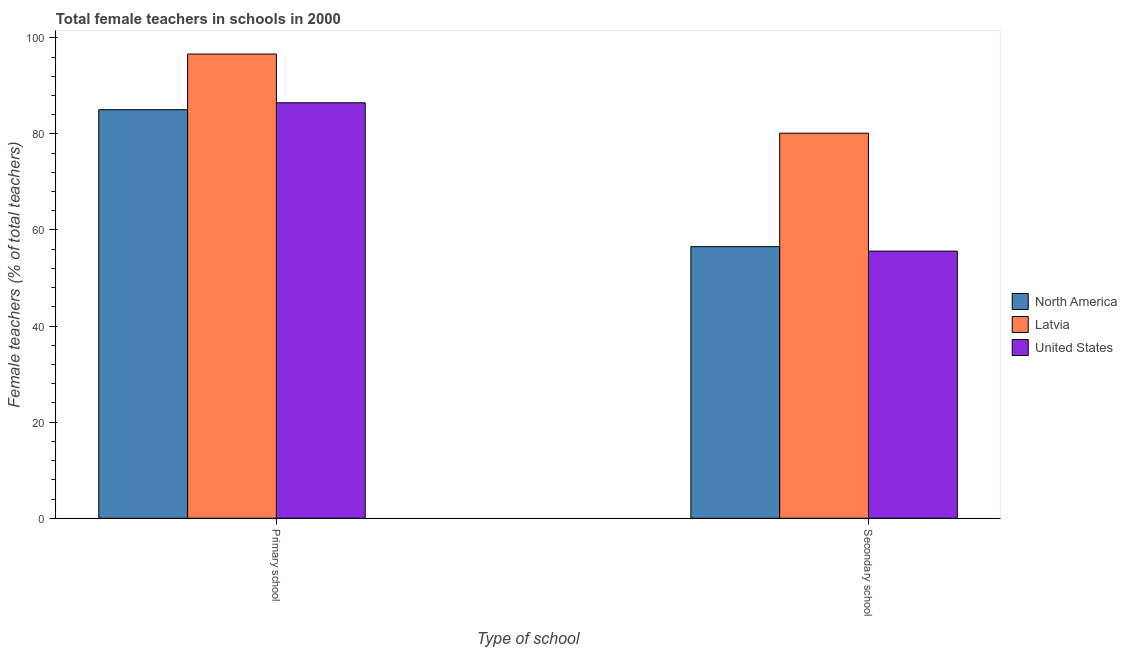Are the number of bars on each tick of the X-axis equal?
Your answer should be compact. Yes. How many bars are there on the 1st tick from the left?
Your answer should be very brief. 3. How many bars are there on the 2nd tick from the right?
Ensure brevity in your answer.  3. What is the label of the 2nd group of bars from the left?
Provide a succinct answer. Secondary school. What is the percentage of female teachers in primary schools in Latvia?
Offer a very short reply. 96.62. Across all countries, what is the maximum percentage of female teachers in primary schools?
Your answer should be very brief. 96.62. Across all countries, what is the minimum percentage of female teachers in secondary schools?
Make the answer very short. 55.6. In which country was the percentage of female teachers in secondary schools maximum?
Your answer should be compact. Latvia. In which country was the percentage of female teachers in primary schools minimum?
Your response must be concise. North America. What is the total percentage of female teachers in primary schools in the graph?
Offer a very short reply. 268.12. What is the difference between the percentage of female teachers in secondary schools in North America and that in Latvia?
Ensure brevity in your answer.  -23.62. What is the difference between the percentage of female teachers in secondary schools in United States and the percentage of female teachers in primary schools in North America?
Your response must be concise. -29.44. What is the average percentage of female teachers in primary schools per country?
Offer a terse response. 89.37. What is the difference between the percentage of female teachers in primary schools and percentage of female teachers in secondary schools in United States?
Make the answer very short. 30.87. What is the ratio of the percentage of female teachers in secondary schools in Latvia to that in United States?
Offer a very short reply. 1.44. Is the percentage of female teachers in primary schools in United States less than that in Latvia?
Your answer should be compact. Yes. What does the 2nd bar from the left in Secondary school represents?
Make the answer very short. Latvia. How many bars are there?
Your answer should be compact. 6. What is the difference between two consecutive major ticks on the Y-axis?
Ensure brevity in your answer.  20. Does the graph contain any zero values?
Make the answer very short. No. Does the graph contain grids?
Offer a terse response. No. Where does the legend appear in the graph?
Your response must be concise. Center right. What is the title of the graph?
Your answer should be compact. Total female teachers in schools in 2000. What is the label or title of the X-axis?
Provide a short and direct response. Type of school. What is the label or title of the Y-axis?
Give a very brief answer. Female teachers (% of total teachers). What is the Female teachers (% of total teachers) of North America in Primary school?
Your answer should be very brief. 85.03. What is the Female teachers (% of total teachers) in Latvia in Primary school?
Keep it short and to the point. 96.62. What is the Female teachers (% of total teachers) of United States in Primary school?
Provide a succinct answer. 86.47. What is the Female teachers (% of total teachers) of North America in Secondary school?
Keep it short and to the point. 56.52. What is the Female teachers (% of total teachers) in Latvia in Secondary school?
Your response must be concise. 80.14. What is the Female teachers (% of total teachers) of United States in Secondary school?
Provide a succinct answer. 55.6. Across all Type of school, what is the maximum Female teachers (% of total teachers) of North America?
Make the answer very short. 85.03. Across all Type of school, what is the maximum Female teachers (% of total teachers) in Latvia?
Offer a very short reply. 96.62. Across all Type of school, what is the maximum Female teachers (% of total teachers) in United States?
Your response must be concise. 86.47. Across all Type of school, what is the minimum Female teachers (% of total teachers) of North America?
Provide a short and direct response. 56.52. Across all Type of school, what is the minimum Female teachers (% of total teachers) of Latvia?
Your answer should be very brief. 80.14. Across all Type of school, what is the minimum Female teachers (% of total teachers) in United States?
Keep it short and to the point. 55.6. What is the total Female teachers (% of total teachers) in North America in the graph?
Your answer should be very brief. 141.56. What is the total Female teachers (% of total teachers) in Latvia in the graph?
Ensure brevity in your answer.  176.76. What is the total Female teachers (% of total teachers) in United States in the graph?
Give a very brief answer. 142.07. What is the difference between the Female teachers (% of total teachers) in North America in Primary school and that in Secondary school?
Provide a short and direct response. 28.51. What is the difference between the Female teachers (% of total teachers) in Latvia in Primary school and that in Secondary school?
Make the answer very short. 16.48. What is the difference between the Female teachers (% of total teachers) in United States in Primary school and that in Secondary school?
Offer a very short reply. 30.87. What is the difference between the Female teachers (% of total teachers) in North America in Primary school and the Female teachers (% of total teachers) in Latvia in Secondary school?
Make the answer very short. 4.89. What is the difference between the Female teachers (% of total teachers) in North America in Primary school and the Female teachers (% of total teachers) in United States in Secondary school?
Your answer should be very brief. 29.44. What is the difference between the Female teachers (% of total teachers) in Latvia in Primary school and the Female teachers (% of total teachers) in United States in Secondary school?
Your response must be concise. 41.02. What is the average Female teachers (% of total teachers) in North America per Type of school?
Your answer should be compact. 70.78. What is the average Female teachers (% of total teachers) in Latvia per Type of school?
Offer a terse response. 88.38. What is the average Female teachers (% of total teachers) of United States per Type of school?
Provide a short and direct response. 71.03. What is the difference between the Female teachers (% of total teachers) of North America and Female teachers (% of total teachers) of Latvia in Primary school?
Your answer should be compact. -11.59. What is the difference between the Female teachers (% of total teachers) of North America and Female teachers (% of total teachers) of United States in Primary school?
Ensure brevity in your answer.  -1.44. What is the difference between the Female teachers (% of total teachers) of Latvia and Female teachers (% of total teachers) of United States in Primary school?
Make the answer very short. 10.15. What is the difference between the Female teachers (% of total teachers) of North America and Female teachers (% of total teachers) of Latvia in Secondary school?
Your answer should be very brief. -23.62. What is the difference between the Female teachers (% of total teachers) of North America and Female teachers (% of total teachers) of United States in Secondary school?
Ensure brevity in your answer.  0.93. What is the difference between the Female teachers (% of total teachers) of Latvia and Female teachers (% of total teachers) of United States in Secondary school?
Provide a succinct answer. 24.54. What is the ratio of the Female teachers (% of total teachers) in North America in Primary school to that in Secondary school?
Offer a very short reply. 1.5. What is the ratio of the Female teachers (% of total teachers) in Latvia in Primary school to that in Secondary school?
Provide a succinct answer. 1.21. What is the ratio of the Female teachers (% of total teachers) of United States in Primary school to that in Secondary school?
Provide a short and direct response. 1.56. What is the difference between the highest and the second highest Female teachers (% of total teachers) in North America?
Give a very brief answer. 28.51. What is the difference between the highest and the second highest Female teachers (% of total teachers) of Latvia?
Provide a short and direct response. 16.48. What is the difference between the highest and the second highest Female teachers (% of total teachers) in United States?
Offer a very short reply. 30.87. What is the difference between the highest and the lowest Female teachers (% of total teachers) of North America?
Ensure brevity in your answer.  28.51. What is the difference between the highest and the lowest Female teachers (% of total teachers) of Latvia?
Your answer should be compact. 16.48. What is the difference between the highest and the lowest Female teachers (% of total teachers) in United States?
Make the answer very short. 30.87. 